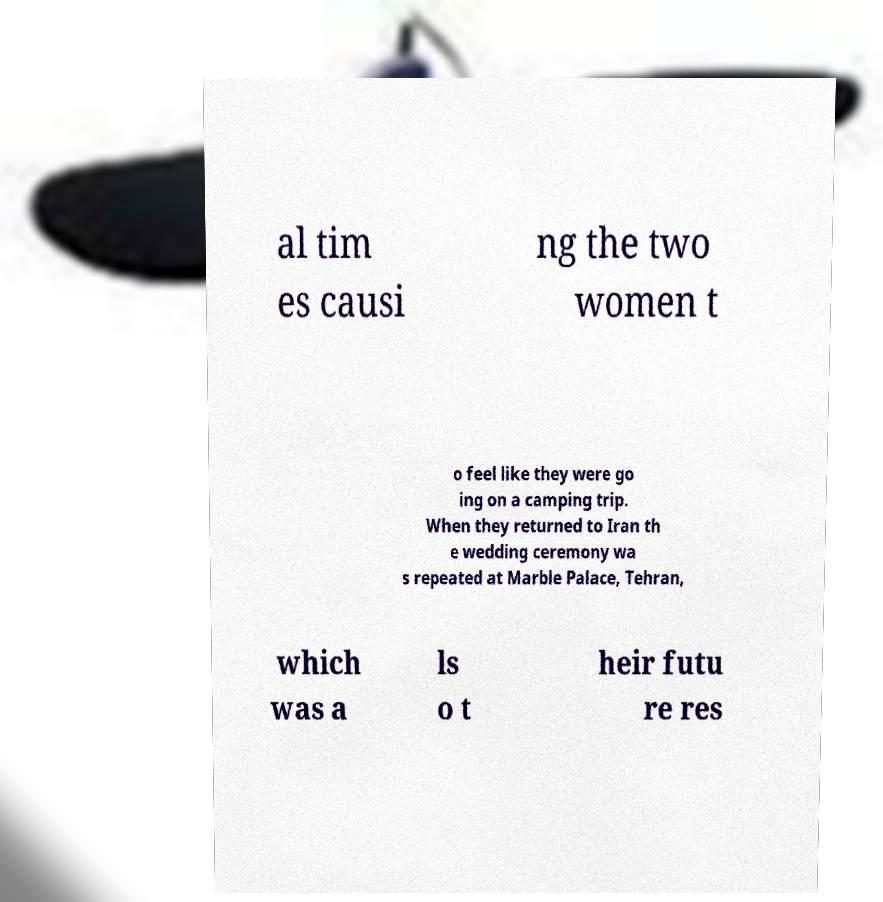What messages or text are displayed in this image? I need them in a readable, typed format. al tim es causi ng the two women t o feel like they were go ing on a camping trip. When they returned to Iran th e wedding ceremony wa s repeated at Marble Palace, Tehran, which was a ls o t heir futu re res 